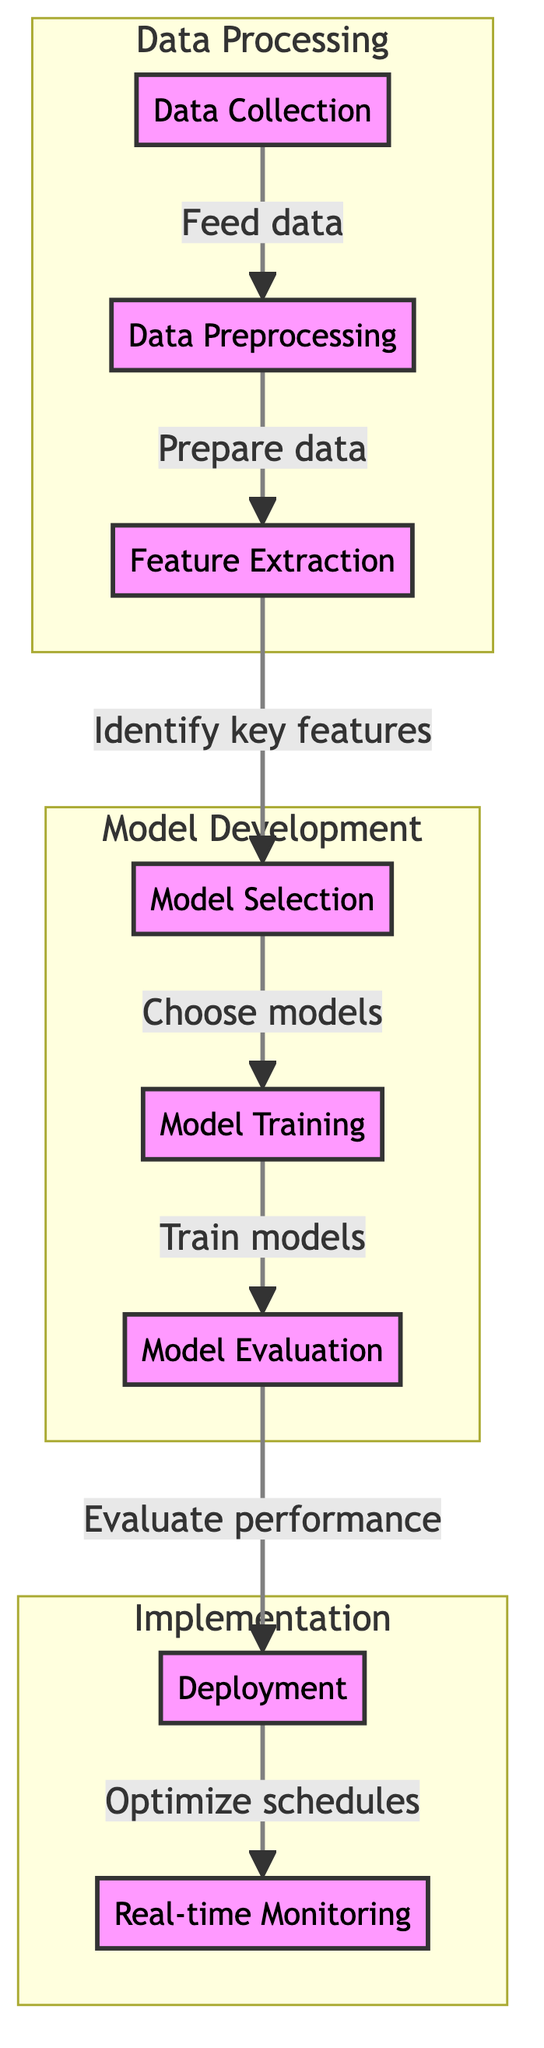What is the first step in the diagram? The diagram indicates that the first step is "Data Collection," shown at the top before any arrows lead to other nodes.
Answer: Data Collection How many main subgraphs are present in the diagram? The diagram contains three main subgraphs: Data Processing, Model Development, and Implementation, as indicated by the distinct groupings in the flowchart.
Answer: Three What is the process that follows "Model Evaluation"? The process that follows "Model Evaluation" is "Deployment," which is connected by an arrow indicating the flow of information.
Answer: Deployment Which node involves training the models? The node labeled "Model Training" is specifically designated for training the models, as indicated by its distinct placement in the model development subgraph.
Answer: Model Training What is the last step in the flow of the diagram? The last step in the diagram is "Real-time Monitoring," which is the final node in the sequence flowing from the preceding "Deployment" step.
Answer: Real-time Monitoring What relationship exists between "Feature Extraction" and "Model Selection"? "Feature Extraction" leads to "Model Selection" in a sequential flow, indicating that identifying key features is a prerequisite for choosing models.
Answer: Sequential flow What is the purpose of "Data Preprocessing"? The purpose of "Data Preprocessing" is to prepare the data for further analysis, as indicated by the arrow leading to the next step, "Feature Extraction."
Answer: Prepare data How many nodes are there in the "Implementation" subgraph? The "Implementation" subgraph contains two nodes: "Deployment" and "Real-time Monitoring," shown clearly in the bottom group of the diagram.
Answer: Two What is the overall goal of the flow described in the diagram? The overall goal is to optimize resource allocation for border patrol through a structured machine learning process, described through the various steps leading to real-time monitoring.
Answer: Optimize schedules 